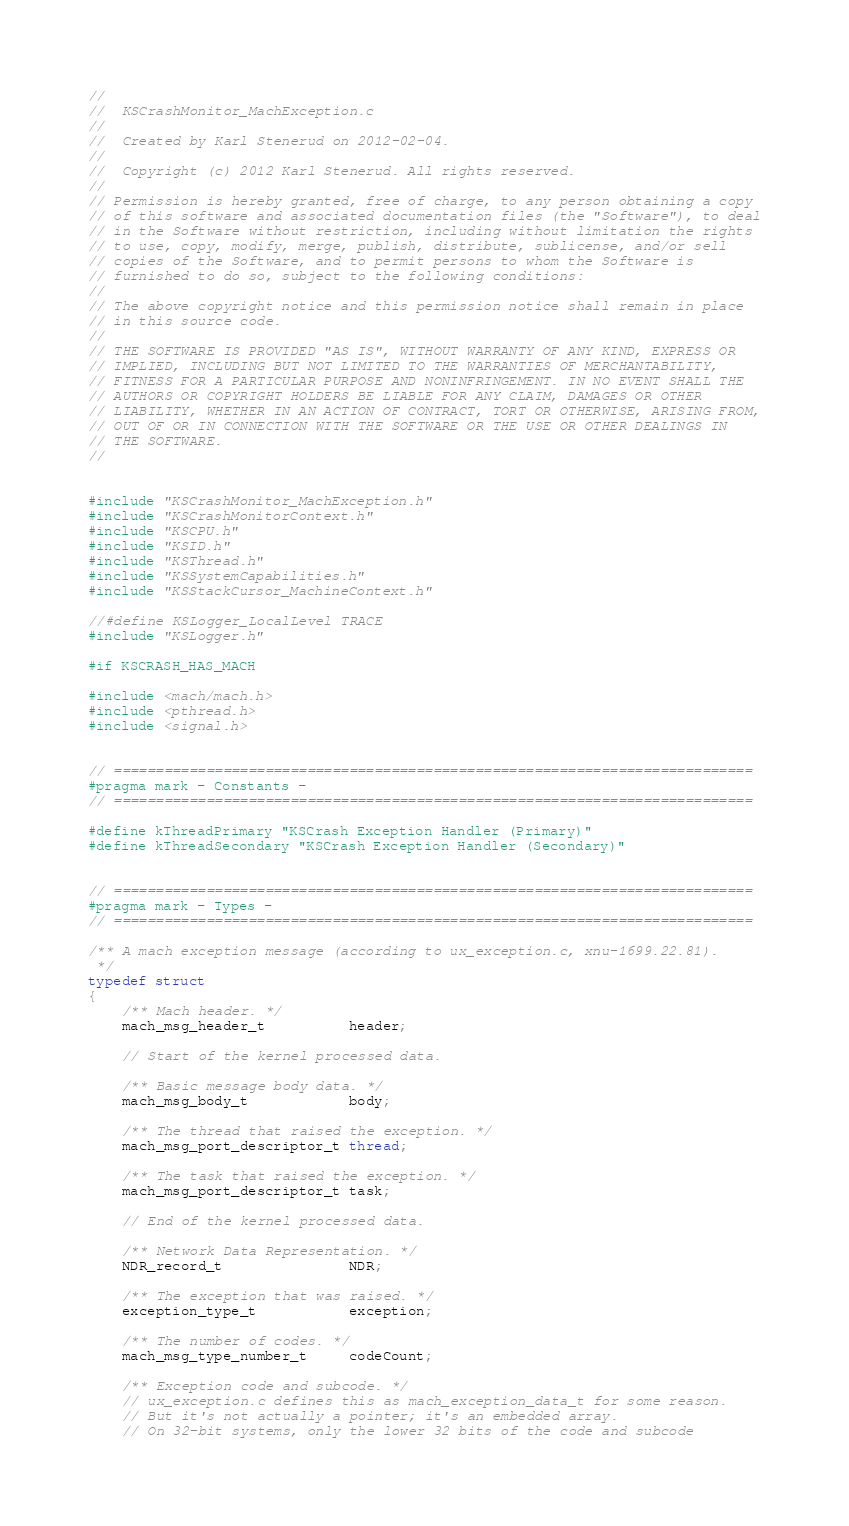<code> <loc_0><loc_0><loc_500><loc_500><_C_>//
//  KSCrashMonitor_MachException.c
//
//  Created by Karl Stenerud on 2012-02-04.
//
//  Copyright (c) 2012 Karl Stenerud. All rights reserved.
//
// Permission is hereby granted, free of charge, to any person obtaining a copy
// of this software and associated documentation files (the "Software"), to deal
// in the Software without restriction, including without limitation the rights
// to use, copy, modify, merge, publish, distribute, sublicense, and/or sell
// copies of the Software, and to permit persons to whom the Software is
// furnished to do so, subject to the following conditions:
//
// The above copyright notice and this permission notice shall remain in place
// in this source code.
//
// THE SOFTWARE IS PROVIDED "AS IS", WITHOUT WARRANTY OF ANY KIND, EXPRESS OR
// IMPLIED, INCLUDING BUT NOT LIMITED TO THE WARRANTIES OF MERCHANTABILITY,
// FITNESS FOR A PARTICULAR PURPOSE AND NONINFRINGEMENT. IN NO EVENT SHALL THE
// AUTHORS OR COPYRIGHT HOLDERS BE LIABLE FOR ANY CLAIM, DAMAGES OR OTHER
// LIABILITY, WHETHER IN AN ACTION OF CONTRACT, TORT OR OTHERWISE, ARISING FROM,
// OUT OF OR IN CONNECTION WITH THE SOFTWARE OR THE USE OR OTHER DEALINGS IN
// THE SOFTWARE.
//


#include "KSCrashMonitor_MachException.h"
#include "KSCrashMonitorContext.h"
#include "KSCPU.h"
#include "KSID.h"
#include "KSThread.h"
#include "KSSystemCapabilities.h"
#include "KSStackCursor_MachineContext.h"

//#define KSLogger_LocalLevel TRACE
#include "KSLogger.h"

#if KSCRASH_HAS_MACH

#include <mach/mach.h>
#include <pthread.h>
#include <signal.h>


// ============================================================================
#pragma mark - Constants -
// ============================================================================

#define kThreadPrimary "KSCrash Exception Handler (Primary)"
#define kThreadSecondary "KSCrash Exception Handler (Secondary)"


// ============================================================================
#pragma mark - Types -
// ============================================================================

/** A mach exception message (according to ux_exception.c, xnu-1699.22.81).
 */
typedef struct
{
    /** Mach header. */
    mach_msg_header_t          header;

    // Start of the kernel processed data.

    /** Basic message body data. */
    mach_msg_body_t            body;

    /** The thread that raised the exception. */
    mach_msg_port_descriptor_t thread;

    /** The task that raised the exception. */
    mach_msg_port_descriptor_t task;

    // End of the kernel processed data.

    /** Network Data Representation. */
    NDR_record_t               NDR;

    /** The exception that was raised. */
    exception_type_t           exception;

    /** The number of codes. */
    mach_msg_type_number_t     codeCount;

    /** Exception code and subcode. */
    // ux_exception.c defines this as mach_exception_data_t for some reason.
    // But it's not actually a pointer; it's an embedded array.
    // On 32-bit systems, only the lower 32 bits of the code and subcode</code> 